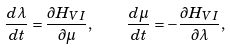Convert formula to latex. <formula><loc_0><loc_0><loc_500><loc_500>\frac { d \lambda } { d t } = \frac { \partial H _ { V I } } { \partial \mu } , \quad \frac { d \mu } { d t } = - \frac { \partial H _ { V I } } { \partial \lambda } ,</formula> 